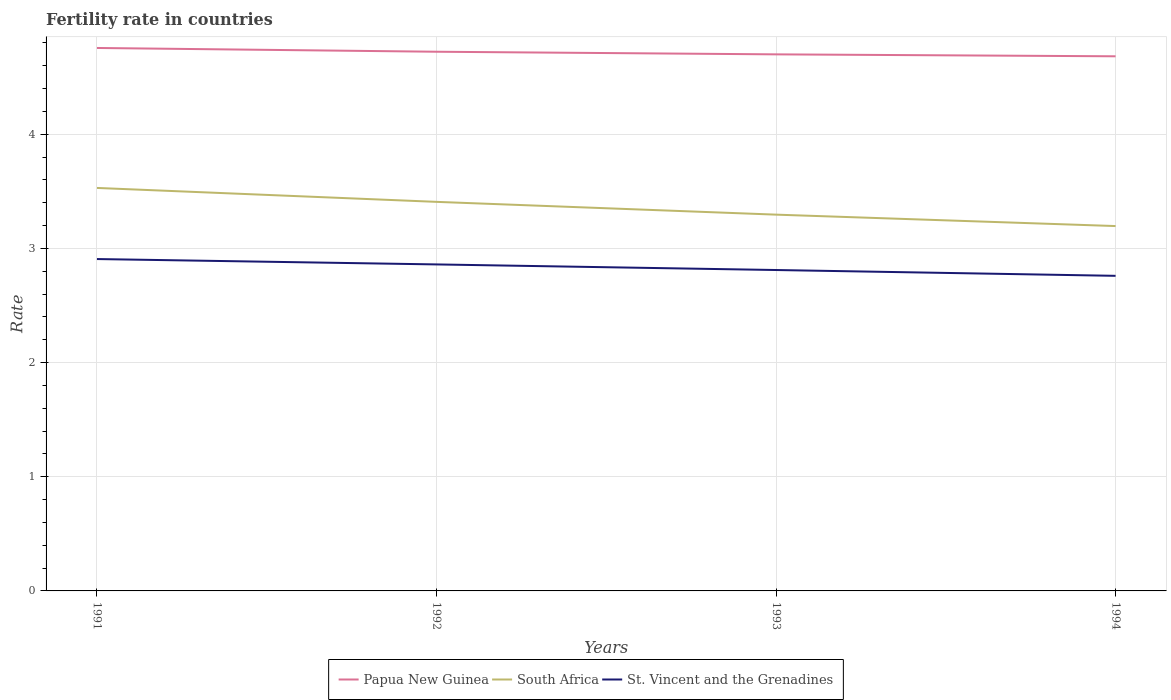Is the number of lines equal to the number of legend labels?
Your response must be concise. Yes. Across all years, what is the maximum fertility rate in South Africa?
Keep it short and to the point. 3.2. What is the total fertility rate in St. Vincent and the Grenadines in the graph?
Your answer should be very brief. 0.1. What is the difference between the highest and the second highest fertility rate in Papua New Guinea?
Ensure brevity in your answer.  0.07. What is the difference between the highest and the lowest fertility rate in Papua New Guinea?
Provide a short and direct response. 2. What is the difference between two consecutive major ticks on the Y-axis?
Your answer should be compact. 1. Does the graph contain any zero values?
Ensure brevity in your answer.  No. Does the graph contain grids?
Give a very brief answer. Yes. Where does the legend appear in the graph?
Give a very brief answer. Bottom center. How many legend labels are there?
Your response must be concise. 3. How are the legend labels stacked?
Keep it short and to the point. Horizontal. What is the title of the graph?
Make the answer very short. Fertility rate in countries. What is the label or title of the X-axis?
Your response must be concise. Years. What is the label or title of the Y-axis?
Provide a short and direct response. Rate. What is the Rate in Papua New Guinea in 1991?
Your response must be concise. 4.76. What is the Rate of South Africa in 1991?
Your response must be concise. 3.53. What is the Rate in St. Vincent and the Grenadines in 1991?
Your answer should be very brief. 2.91. What is the Rate in Papua New Guinea in 1992?
Keep it short and to the point. 4.72. What is the Rate in South Africa in 1992?
Give a very brief answer. 3.41. What is the Rate in St. Vincent and the Grenadines in 1992?
Provide a succinct answer. 2.86. What is the Rate of Papua New Guinea in 1993?
Make the answer very short. 4.7. What is the Rate in South Africa in 1993?
Your answer should be very brief. 3.3. What is the Rate in St. Vincent and the Grenadines in 1993?
Your response must be concise. 2.81. What is the Rate in Papua New Guinea in 1994?
Give a very brief answer. 4.68. What is the Rate of South Africa in 1994?
Offer a terse response. 3.2. What is the Rate in St. Vincent and the Grenadines in 1994?
Provide a succinct answer. 2.76. Across all years, what is the maximum Rate in Papua New Guinea?
Provide a succinct answer. 4.76. Across all years, what is the maximum Rate in South Africa?
Offer a terse response. 3.53. Across all years, what is the maximum Rate of St. Vincent and the Grenadines?
Provide a succinct answer. 2.91. Across all years, what is the minimum Rate in Papua New Guinea?
Provide a short and direct response. 4.68. Across all years, what is the minimum Rate of South Africa?
Your response must be concise. 3.2. Across all years, what is the minimum Rate of St. Vincent and the Grenadines?
Give a very brief answer. 2.76. What is the total Rate of Papua New Guinea in the graph?
Make the answer very short. 18.86. What is the total Rate in South Africa in the graph?
Provide a short and direct response. 13.43. What is the total Rate of St. Vincent and the Grenadines in the graph?
Keep it short and to the point. 11.34. What is the difference between the Rate of Papua New Guinea in 1991 and that in 1992?
Make the answer very short. 0.03. What is the difference between the Rate in South Africa in 1991 and that in 1992?
Offer a very short reply. 0.12. What is the difference between the Rate in St. Vincent and the Grenadines in 1991 and that in 1992?
Provide a short and direct response. 0.05. What is the difference between the Rate in Papua New Guinea in 1991 and that in 1993?
Provide a short and direct response. 0.06. What is the difference between the Rate in South Africa in 1991 and that in 1993?
Your answer should be very brief. 0.23. What is the difference between the Rate of St. Vincent and the Grenadines in 1991 and that in 1993?
Your answer should be compact. 0.1. What is the difference between the Rate in Papua New Guinea in 1991 and that in 1994?
Your answer should be very brief. 0.07. What is the difference between the Rate in South Africa in 1991 and that in 1994?
Your answer should be compact. 0.33. What is the difference between the Rate in St. Vincent and the Grenadines in 1991 and that in 1994?
Keep it short and to the point. 0.15. What is the difference between the Rate of Papua New Guinea in 1992 and that in 1993?
Keep it short and to the point. 0.02. What is the difference between the Rate of South Africa in 1992 and that in 1993?
Your answer should be very brief. 0.11. What is the difference between the Rate in St. Vincent and the Grenadines in 1992 and that in 1993?
Ensure brevity in your answer.  0.05. What is the difference between the Rate in Papua New Guinea in 1992 and that in 1994?
Your answer should be very brief. 0.04. What is the difference between the Rate in South Africa in 1992 and that in 1994?
Give a very brief answer. 0.21. What is the difference between the Rate of Papua New Guinea in 1993 and that in 1994?
Give a very brief answer. 0.02. What is the difference between the Rate of St. Vincent and the Grenadines in 1993 and that in 1994?
Give a very brief answer. 0.05. What is the difference between the Rate of Papua New Guinea in 1991 and the Rate of South Africa in 1992?
Provide a succinct answer. 1.35. What is the difference between the Rate of Papua New Guinea in 1991 and the Rate of St. Vincent and the Grenadines in 1992?
Make the answer very short. 1.9. What is the difference between the Rate of South Africa in 1991 and the Rate of St. Vincent and the Grenadines in 1992?
Give a very brief answer. 0.67. What is the difference between the Rate in Papua New Guinea in 1991 and the Rate in South Africa in 1993?
Provide a short and direct response. 1.46. What is the difference between the Rate in Papua New Guinea in 1991 and the Rate in St. Vincent and the Grenadines in 1993?
Offer a terse response. 1.95. What is the difference between the Rate of South Africa in 1991 and the Rate of St. Vincent and the Grenadines in 1993?
Give a very brief answer. 0.72. What is the difference between the Rate of Papua New Guinea in 1991 and the Rate of South Africa in 1994?
Your answer should be compact. 1.56. What is the difference between the Rate of Papua New Guinea in 1991 and the Rate of St. Vincent and the Grenadines in 1994?
Your answer should be very brief. 2. What is the difference between the Rate in South Africa in 1991 and the Rate in St. Vincent and the Grenadines in 1994?
Offer a terse response. 0.77. What is the difference between the Rate in Papua New Guinea in 1992 and the Rate in South Africa in 1993?
Offer a very short reply. 1.43. What is the difference between the Rate in Papua New Guinea in 1992 and the Rate in St. Vincent and the Grenadines in 1993?
Your answer should be compact. 1.91. What is the difference between the Rate in South Africa in 1992 and the Rate in St. Vincent and the Grenadines in 1993?
Your response must be concise. 0.6. What is the difference between the Rate of Papua New Guinea in 1992 and the Rate of South Africa in 1994?
Ensure brevity in your answer.  1.53. What is the difference between the Rate of Papua New Guinea in 1992 and the Rate of St. Vincent and the Grenadines in 1994?
Offer a very short reply. 1.96. What is the difference between the Rate of South Africa in 1992 and the Rate of St. Vincent and the Grenadines in 1994?
Provide a succinct answer. 0.65. What is the difference between the Rate in Papua New Guinea in 1993 and the Rate in South Africa in 1994?
Provide a succinct answer. 1.5. What is the difference between the Rate in Papua New Guinea in 1993 and the Rate in St. Vincent and the Grenadines in 1994?
Give a very brief answer. 1.94. What is the difference between the Rate of South Africa in 1993 and the Rate of St. Vincent and the Grenadines in 1994?
Offer a terse response. 0.54. What is the average Rate in Papua New Guinea per year?
Make the answer very short. 4.72. What is the average Rate of South Africa per year?
Keep it short and to the point. 3.36. What is the average Rate in St. Vincent and the Grenadines per year?
Your answer should be compact. 2.83. In the year 1991, what is the difference between the Rate in Papua New Guinea and Rate in South Africa?
Make the answer very short. 1.23. In the year 1991, what is the difference between the Rate in Papua New Guinea and Rate in St. Vincent and the Grenadines?
Keep it short and to the point. 1.85. In the year 1991, what is the difference between the Rate of South Africa and Rate of St. Vincent and the Grenadines?
Your answer should be compact. 0.62. In the year 1992, what is the difference between the Rate of Papua New Guinea and Rate of South Africa?
Provide a short and direct response. 1.31. In the year 1992, what is the difference between the Rate of Papua New Guinea and Rate of St. Vincent and the Grenadines?
Your answer should be very brief. 1.86. In the year 1992, what is the difference between the Rate in South Africa and Rate in St. Vincent and the Grenadines?
Your answer should be very brief. 0.55. In the year 1993, what is the difference between the Rate of Papua New Guinea and Rate of South Africa?
Make the answer very short. 1.4. In the year 1993, what is the difference between the Rate of Papua New Guinea and Rate of St. Vincent and the Grenadines?
Your answer should be compact. 1.89. In the year 1993, what is the difference between the Rate in South Africa and Rate in St. Vincent and the Grenadines?
Make the answer very short. 0.48. In the year 1994, what is the difference between the Rate of Papua New Guinea and Rate of South Africa?
Offer a terse response. 1.49. In the year 1994, what is the difference between the Rate in Papua New Guinea and Rate in St. Vincent and the Grenadines?
Your answer should be compact. 1.92. In the year 1994, what is the difference between the Rate of South Africa and Rate of St. Vincent and the Grenadines?
Keep it short and to the point. 0.44. What is the ratio of the Rate of South Africa in 1991 to that in 1992?
Offer a terse response. 1.04. What is the ratio of the Rate in St. Vincent and the Grenadines in 1991 to that in 1992?
Provide a short and direct response. 1.02. What is the ratio of the Rate in Papua New Guinea in 1991 to that in 1993?
Your response must be concise. 1.01. What is the ratio of the Rate of South Africa in 1991 to that in 1993?
Your answer should be very brief. 1.07. What is the ratio of the Rate in St. Vincent and the Grenadines in 1991 to that in 1993?
Provide a short and direct response. 1.03. What is the ratio of the Rate of Papua New Guinea in 1991 to that in 1994?
Offer a very short reply. 1.02. What is the ratio of the Rate in South Africa in 1991 to that in 1994?
Give a very brief answer. 1.1. What is the ratio of the Rate of St. Vincent and the Grenadines in 1991 to that in 1994?
Provide a short and direct response. 1.05. What is the ratio of the Rate of Papua New Guinea in 1992 to that in 1993?
Your answer should be compact. 1. What is the ratio of the Rate of South Africa in 1992 to that in 1993?
Make the answer very short. 1.03. What is the ratio of the Rate in St. Vincent and the Grenadines in 1992 to that in 1993?
Provide a short and direct response. 1.02. What is the ratio of the Rate of Papua New Guinea in 1992 to that in 1994?
Your answer should be compact. 1.01. What is the ratio of the Rate of South Africa in 1992 to that in 1994?
Your answer should be compact. 1.07. What is the ratio of the Rate of St. Vincent and the Grenadines in 1992 to that in 1994?
Your answer should be very brief. 1.04. What is the ratio of the Rate of South Africa in 1993 to that in 1994?
Make the answer very short. 1.03. What is the ratio of the Rate of St. Vincent and the Grenadines in 1993 to that in 1994?
Your response must be concise. 1.02. What is the difference between the highest and the second highest Rate of Papua New Guinea?
Make the answer very short. 0.03. What is the difference between the highest and the second highest Rate of South Africa?
Provide a succinct answer. 0.12. What is the difference between the highest and the second highest Rate of St. Vincent and the Grenadines?
Ensure brevity in your answer.  0.05. What is the difference between the highest and the lowest Rate of Papua New Guinea?
Your response must be concise. 0.07. What is the difference between the highest and the lowest Rate in South Africa?
Provide a succinct answer. 0.33. What is the difference between the highest and the lowest Rate in St. Vincent and the Grenadines?
Provide a succinct answer. 0.15. 